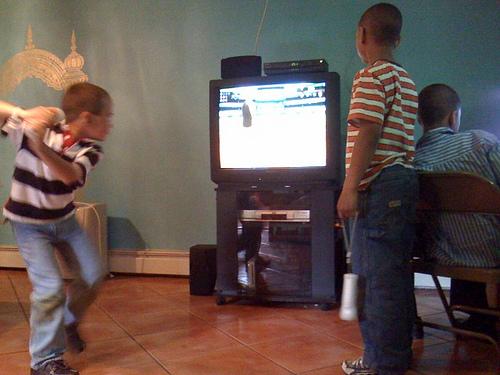How many boys are shown?
Concise answer only. 3. Is there carpeting on the floor?
Give a very brief answer. No. Which gaming console do you think these children are using?
Short answer required. Wii. 